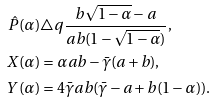<formula> <loc_0><loc_0><loc_500><loc_500>\hat { P } ( \alpha ) & \triangle q \frac { b \sqrt { 1 - \alpha } - a } { a b ( 1 - \sqrt { 1 - \alpha } ) } , \\ X ( \alpha ) & = \alpha a b - \bar { \gamma } ( a + b ) , \\ Y ( \alpha ) & = 4 \bar { \gamma } a b ( \bar { \gamma } - a + b ( 1 - \alpha ) ) .</formula> 